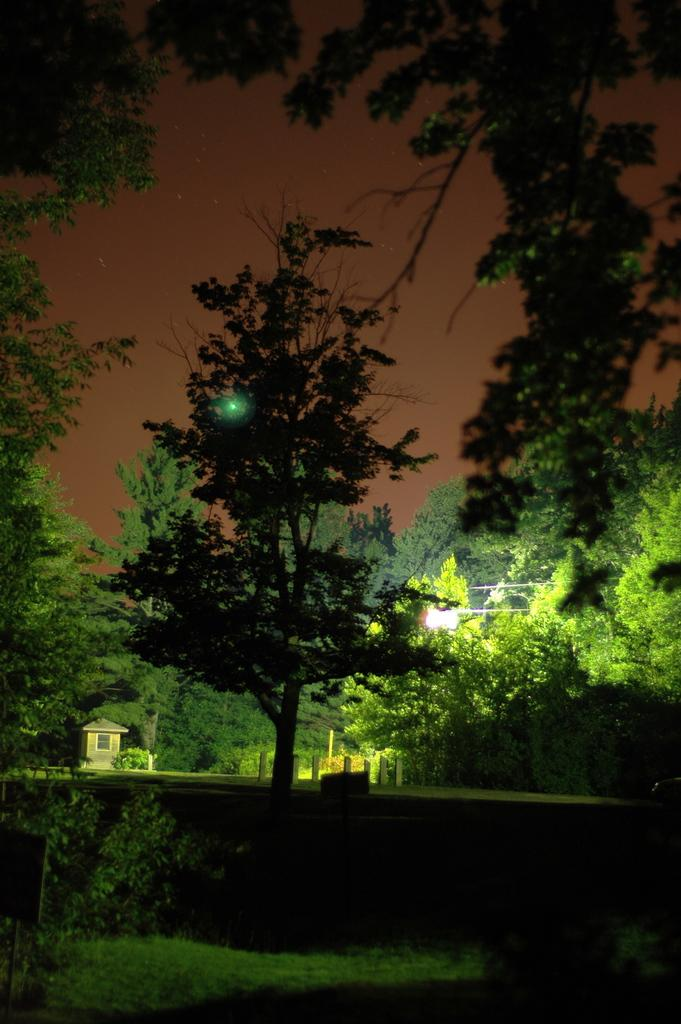What is the main subject in the center of the image? There is a tree in the center of the image. What is the tree standing on? The tree is on the grass. What can be seen in the background of the image? There are trees, a pole, a shed, and the sky visible in the background of the image. What type of riddle can be solved by looking at the tree in the image? There is no riddle present in the image, and therefore no such riddle can be solved by looking at the tree. 